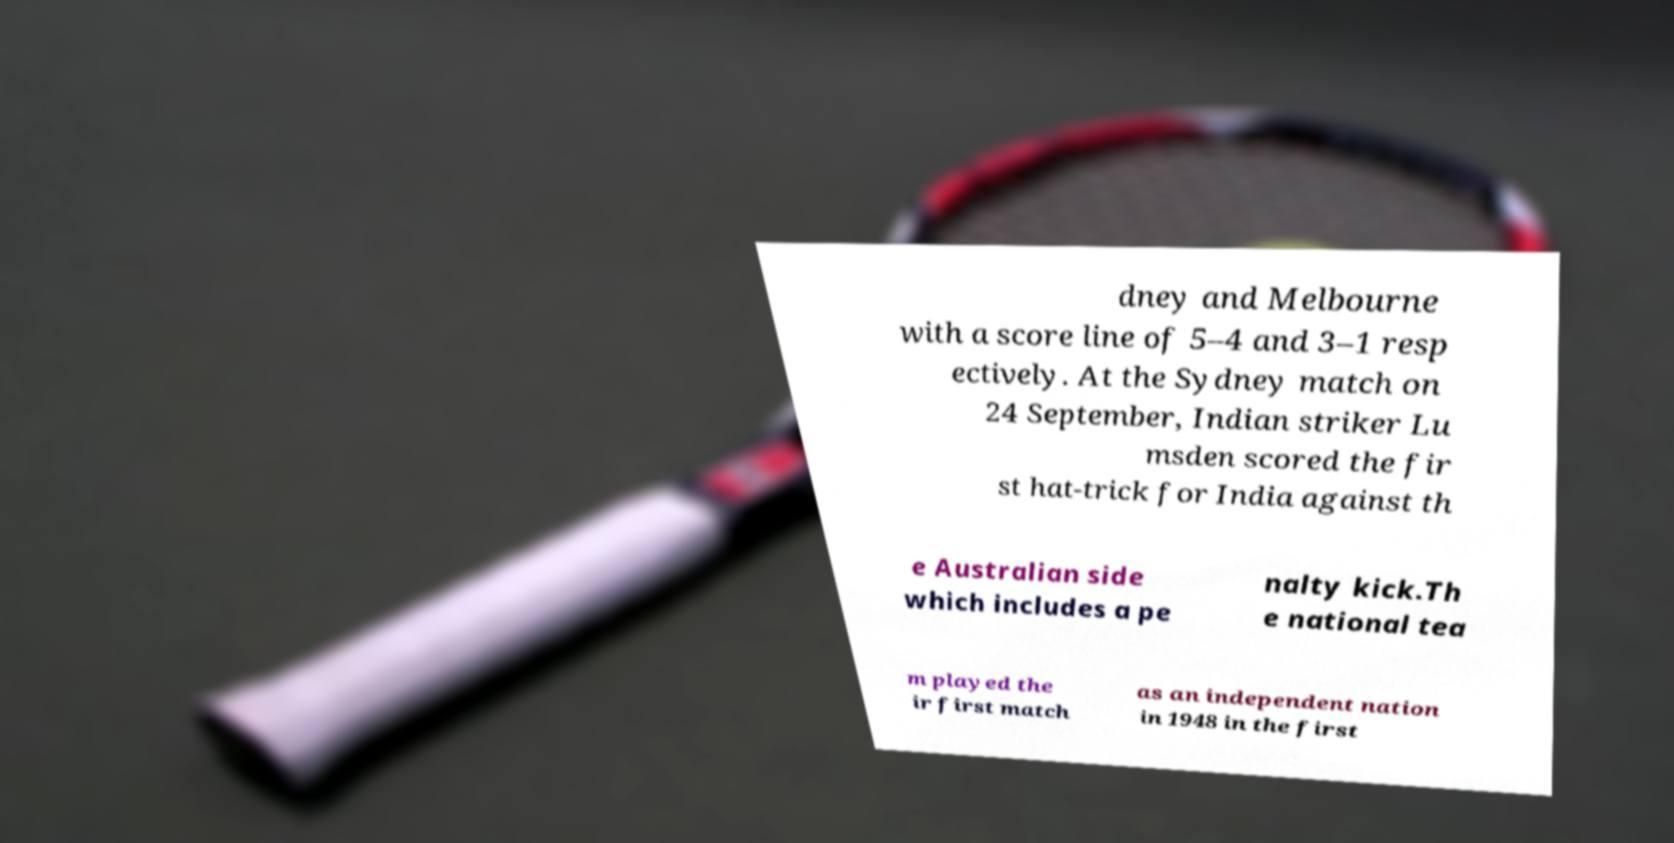Can you accurately transcribe the text from the provided image for me? dney and Melbourne with a score line of 5–4 and 3–1 resp ectively. At the Sydney match on 24 September, Indian striker Lu msden scored the fir st hat-trick for India against th e Australian side which includes a pe nalty kick.Th e national tea m played the ir first match as an independent nation in 1948 in the first 